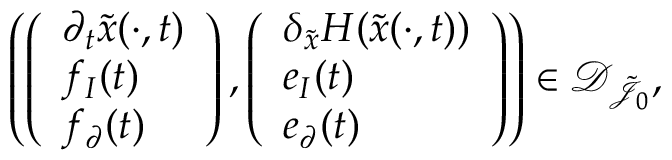Convert formula to latex. <formula><loc_0><loc_0><loc_500><loc_500>\begin{array} { r } { \left ( \left ( \begin{array} { l } { \partial _ { t } \tilde { x } ( \cdot , t ) } \\ { f _ { I } ( t ) } \\ { f _ { \partial } ( t ) } \end{array} \right ) , \left ( \begin{array} { l } { \delta _ { \tilde { x } } H ( \tilde { x } ( \cdot , t ) ) } \\ { e _ { I } ( t ) } \\ { e _ { \partial } ( t ) } \end{array} \right ) \right ) \in \mathcal { D } _ { \tilde { \mathcal { J } } _ { 0 } } , } \end{array}</formula> 